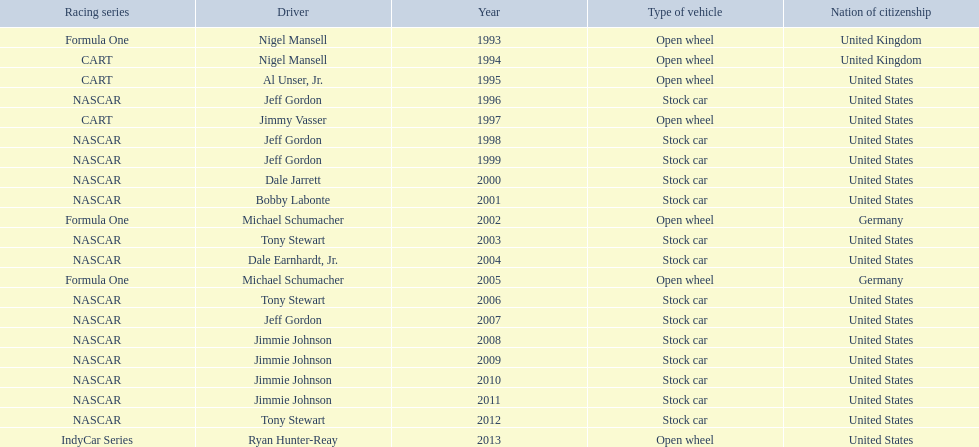Which drivers have won the best driver espy award? Nigel Mansell, Nigel Mansell, Al Unser, Jr., Jeff Gordon, Jimmy Vasser, Jeff Gordon, Jeff Gordon, Dale Jarrett, Bobby Labonte, Michael Schumacher, Tony Stewart, Dale Earnhardt, Jr., Michael Schumacher, Tony Stewart, Jeff Gordon, Jimmie Johnson, Jimmie Johnson, Jimmie Johnson, Jimmie Johnson, Tony Stewart, Ryan Hunter-Reay. Of these, which only appear once? Al Unser, Jr., Jimmy Vasser, Dale Jarrett, Dale Earnhardt, Jr., Ryan Hunter-Reay. Which of these are from the cart racing series? Al Unser, Jr., Jimmy Vasser. Of these, which received their award first? Al Unser, Jr. 